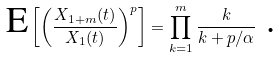<formula> <loc_0><loc_0><loc_500><loc_500>\text {E} \left [ \left ( \frac { X _ { 1 + m } ( t ) } { X _ { 1 } ( t ) } \right ) ^ { p } \right ] = \prod _ { k = 1 } ^ { m } \frac { k } { k + p / \alpha } \text { .}</formula> 